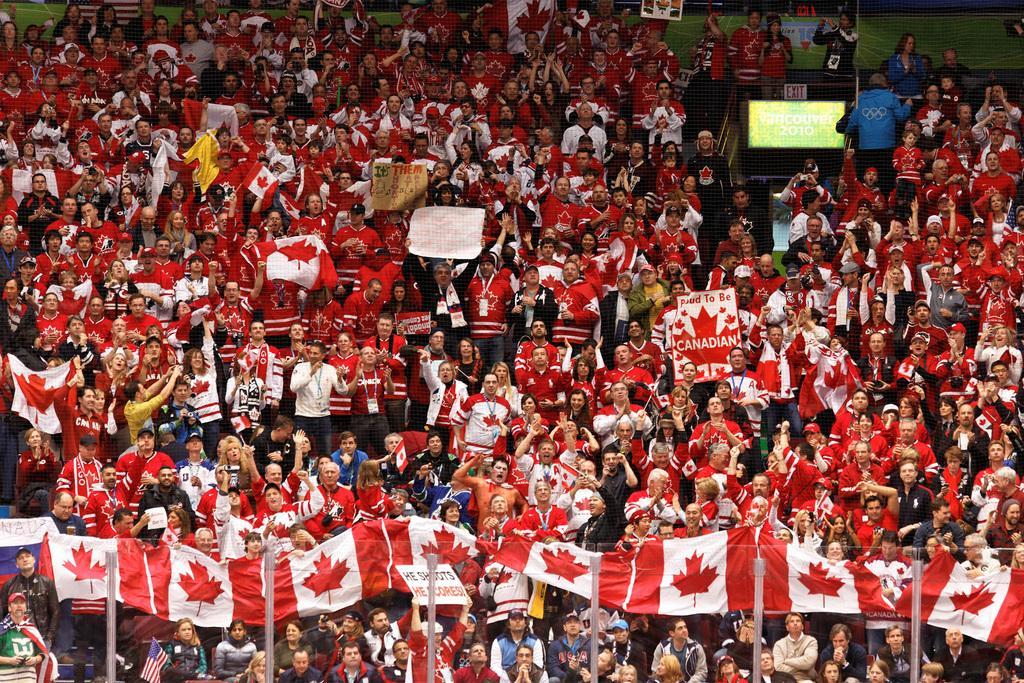Please provide a concise description of this image. Here in this picture we can see number of people sitting and standing in the stands, as we can see all of them are wearing same kind of t shirts and some people in the front are carrying flags and some people are holding placards and in the front we can see fencing present and all of them are cheering. 